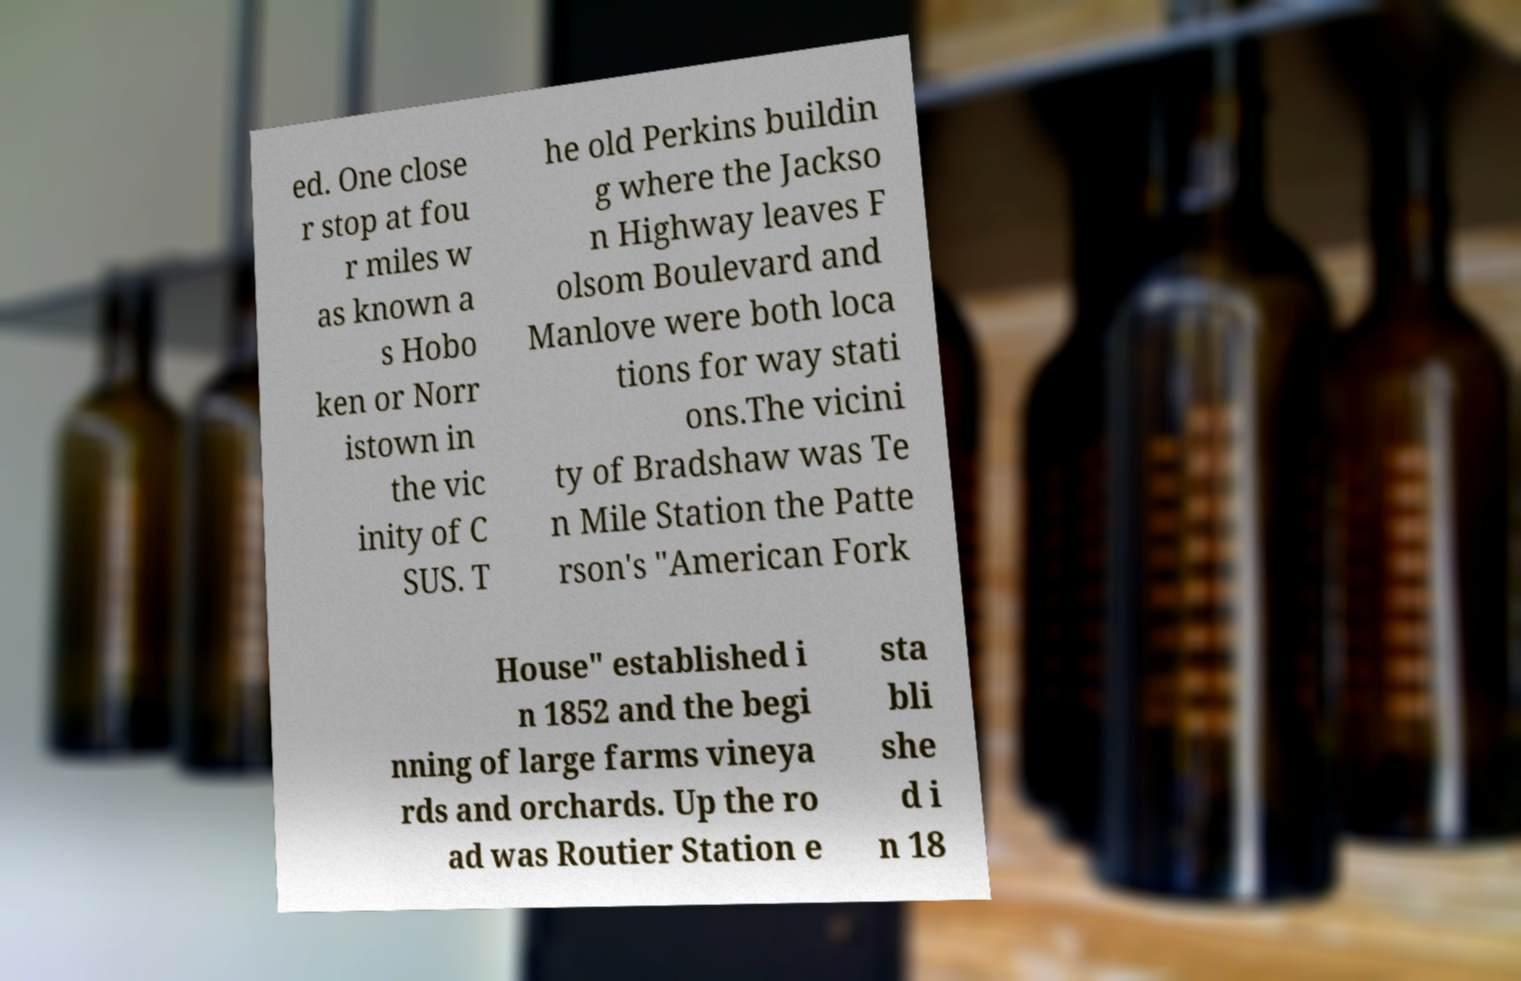What messages or text are displayed in this image? I need them in a readable, typed format. ed. One close r stop at fou r miles w as known a s Hobo ken or Norr istown in the vic inity of C SUS. T he old Perkins buildin g where the Jackso n Highway leaves F olsom Boulevard and Manlove were both loca tions for way stati ons.The vicini ty of Bradshaw was Te n Mile Station the Patte rson's "American Fork House" established i n 1852 and the begi nning of large farms vineya rds and orchards. Up the ro ad was Routier Station e sta bli she d i n 18 